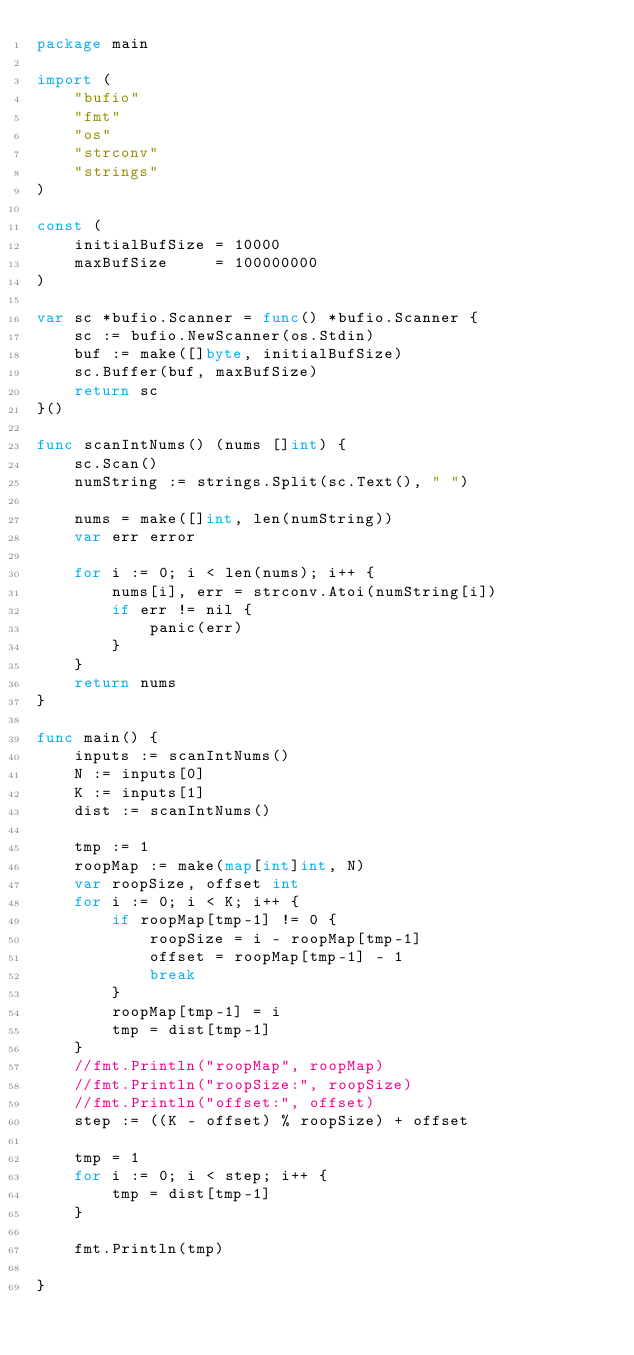<code> <loc_0><loc_0><loc_500><loc_500><_Go_>package main

import (
	"bufio"
	"fmt"
	"os"
	"strconv"
	"strings"
)

const (
	initialBufSize = 10000
	maxBufSize     = 100000000
)

var sc *bufio.Scanner = func() *bufio.Scanner {
	sc := bufio.NewScanner(os.Stdin)
	buf := make([]byte, initialBufSize)
	sc.Buffer(buf, maxBufSize)
	return sc
}()

func scanIntNums() (nums []int) {
	sc.Scan()
	numString := strings.Split(sc.Text(), " ")

	nums = make([]int, len(numString))
	var err error

	for i := 0; i < len(nums); i++ {
		nums[i], err = strconv.Atoi(numString[i])
		if err != nil {
			panic(err)
		}
	}
	return nums
}

func main() {
	inputs := scanIntNums()
	N := inputs[0]
	K := inputs[1]
	dist := scanIntNums()

	tmp := 1
	roopMap := make(map[int]int, N)
	var roopSize, offset int
	for i := 0; i < K; i++ {
		if roopMap[tmp-1] != 0 {
			roopSize = i - roopMap[tmp-1]
			offset = roopMap[tmp-1] - 1
			break
		}
		roopMap[tmp-1] = i
		tmp = dist[tmp-1]
	}
	//fmt.Println("roopMap", roopMap)
	//fmt.Println("roopSize:", roopSize)
	//fmt.Println("offset:", offset)
	step := ((K - offset) % roopSize) + offset

	tmp = 1
	for i := 0; i < step; i++ {
		tmp = dist[tmp-1]
	}

	fmt.Println(tmp)

}
</code> 